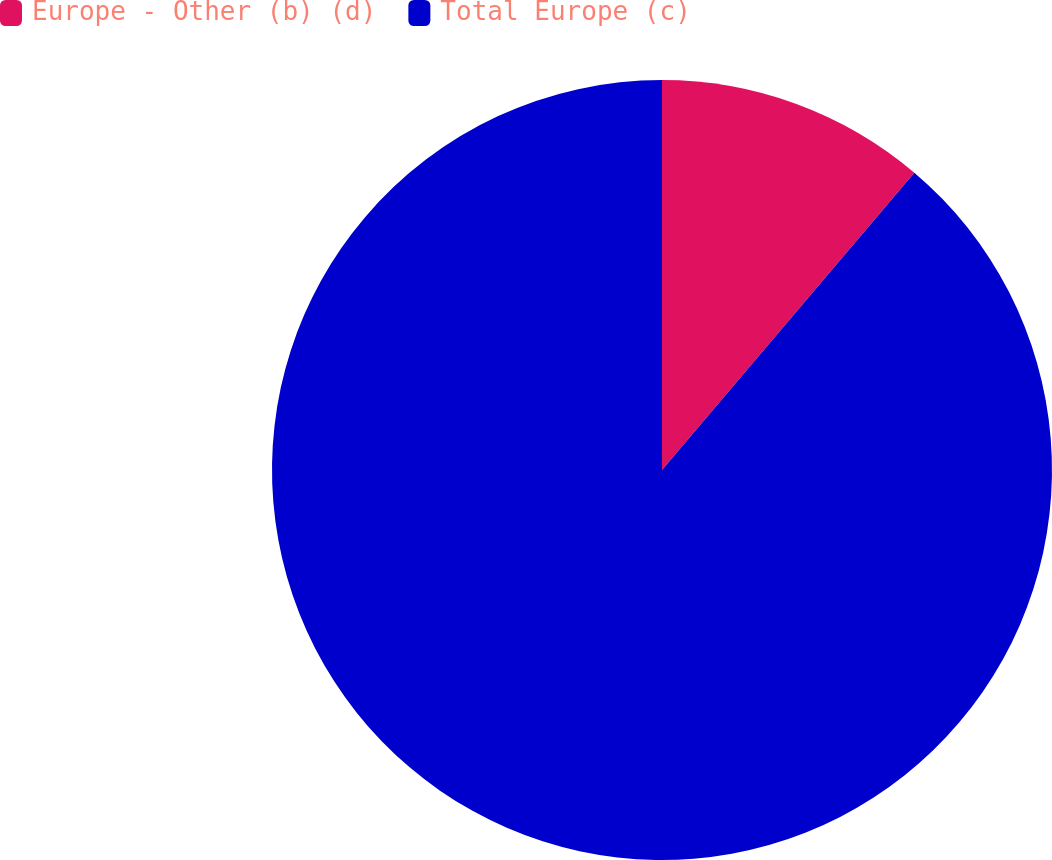Convert chart. <chart><loc_0><loc_0><loc_500><loc_500><pie_chart><fcel>Europe - Other (b) (d)<fcel>Total Europe (c)<nl><fcel>11.2%<fcel>88.8%<nl></chart> 